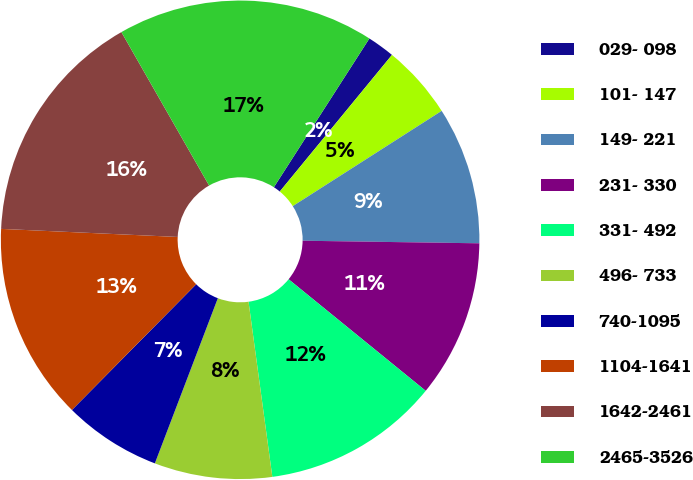<chart> <loc_0><loc_0><loc_500><loc_500><pie_chart><fcel>029- 098<fcel>101- 147<fcel>149- 221<fcel>231- 330<fcel>331- 492<fcel>496- 733<fcel>740-1095<fcel>1104-1641<fcel>1642-2461<fcel>2465-3526<nl><fcel>1.86%<fcel>5.0%<fcel>9.29%<fcel>10.64%<fcel>11.98%<fcel>7.95%<fcel>6.61%<fcel>13.32%<fcel>16.01%<fcel>17.35%<nl></chart> 